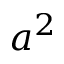Convert formula to latex. <formula><loc_0><loc_0><loc_500><loc_500>a ^ { 2 }</formula> 